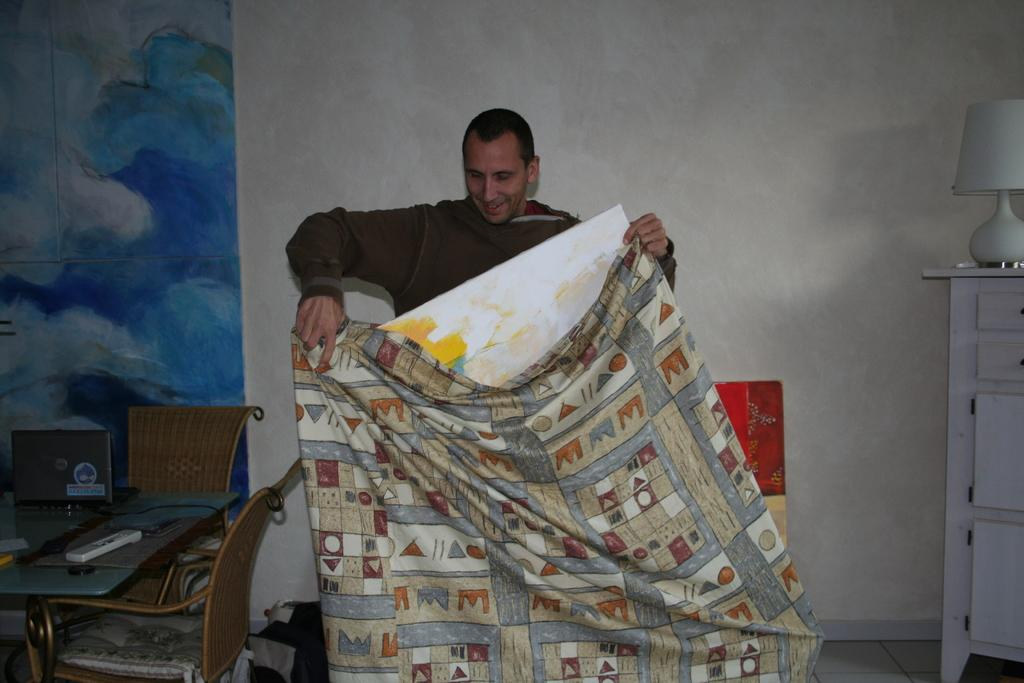Who is present in the image? There is a man in the image. What is the man holding in his hands? The man is holding a blanket and a cardboard with paint on it. What can be seen behind the man? There is a TV and chairs behind the man. What type of veil is the man wearing in the image? There is no veil present in the image; the man is holding a blanket and a cardboard with paint on it. 